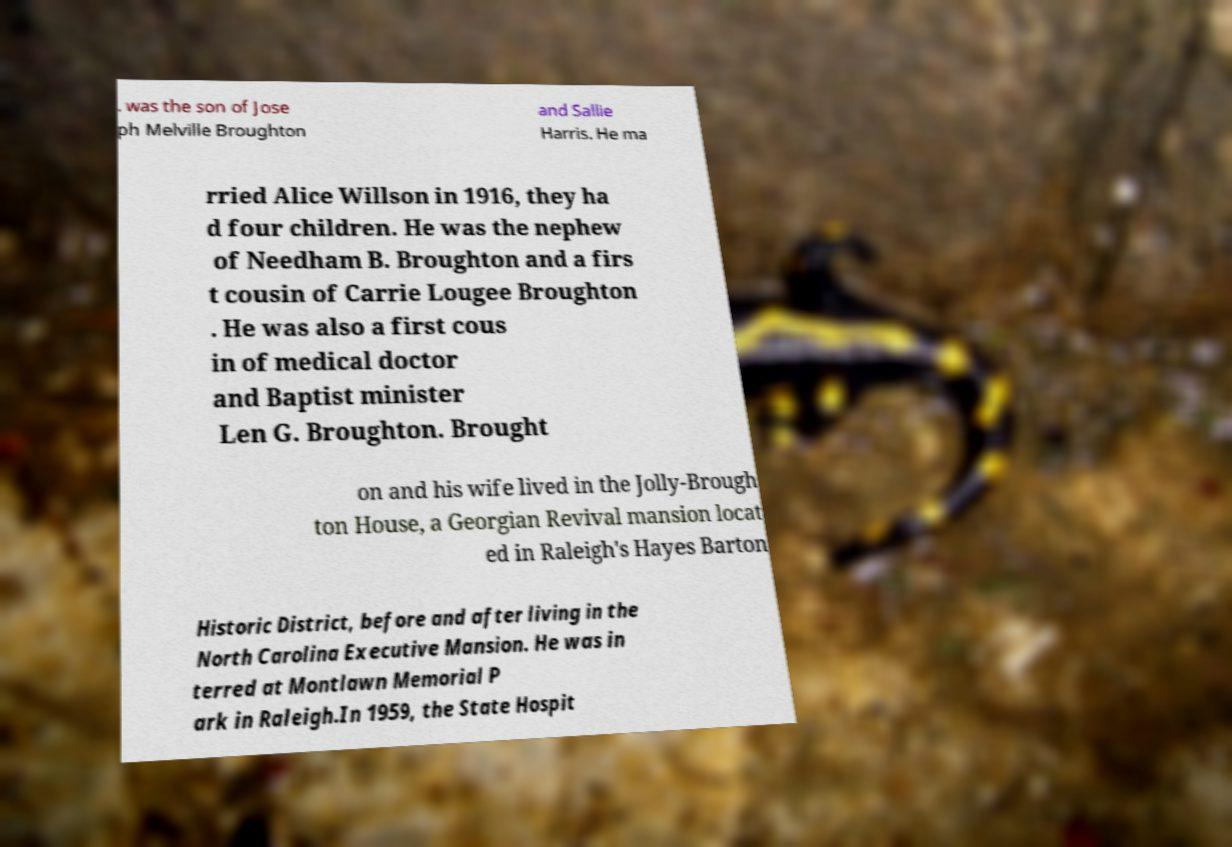I need the written content from this picture converted into text. Can you do that? . was the son of Jose ph Melville Broughton and Sallie Harris. He ma rried Alice Willson in 1916, they ha d four children. He was the nephew of Needham B. Broughton and a firs t cousin of Carrie Lougee Broughton . He was also a first cous in of medical doctor and Baptist minister Len G. Broughton. Brought on and his wife lived in the Jolly-Brough ton House, a Georgian Revival mansion locat ed in Raleigh's Hayes Barton Historic District, before and after living in the North Carolina Executive Mansion. He was in terred at Montlawn Memorial P ark in Raleigh.In 1959, the State Hospit 